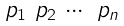Convert formula to latex. <formula><loc_0><loc_0><loc_500><loc_500>\begin{smallmatrix} p _ { 1 } & p _ { 2 } & \cdots & p _ { n } \end{smallmatrix}</formula> 